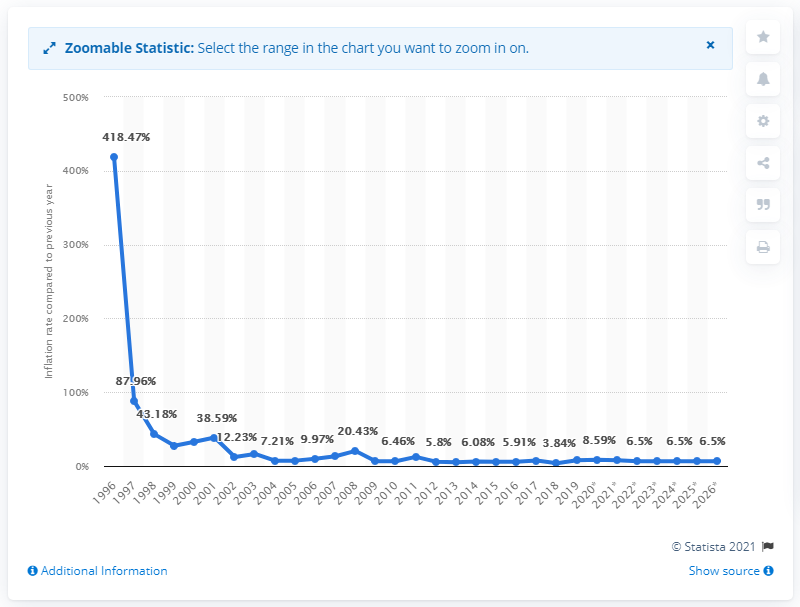Mention a couple of crucial points in this snapshot. The average inflation rate in Tajikistan was in 1996. 